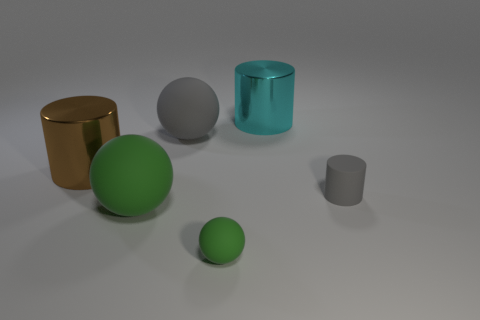There is a tiny object that is to the right of the cyan metallic object; is it the same color as the big matte sphere behind the tiny gray matte object?
Your answer should be very brief. Yes. What color is the object that is on the left side of the big gray object and in front of the gray matte cylinder?
Your answer should be very brief. Green. Are there any other big matte cylinders of the same color as the matte cylinder?
Ensure brevity in your answer.  No. Are the big cylinder that is left of the large gray matte object and the big cylinder behind the brown cylinder made of the same material?
Your answer should be very brief. Yes. There is a gray thing on the right side of the big cyan metal cylinder; what size is it?
Give a very brief answer. Small. What is the size of the gray cylinder?
Provide a succinct answer. Small. There is a green ball that is in front of the large rubber sphere that is in front of the big cylinder in front of the large cyan metal cylinder; what is its size?
Your response must be concise. Small. Are there any small spheres made of the same material as the cyan object?
Offer a very short reply. No. What is the shape of the tiny gray thing?
Your answer should be compact. Cylinder. What color is the large object that is made of the same material as the large brown cylinder?
Provide a succinct answer. Cyan. 